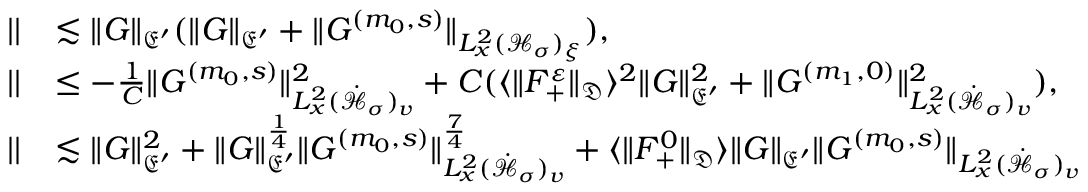<formula> <loc_0><loc_0><loc_500><loc_500>\begin{array} { r l } { | | } & { \lesssim \| G \| _ { \mathfrak E ^ { \prime } } ( \| G \| _ { \mathfrak E ^ { \prime } } + \| G ^ { ( m _ { 0 } , s ) } \| _ { L _ { x } ^ { 2 } ( \mathcal { H } _ { \sigma } ) _ { \xi } } ) , } \\ { | | } & { \leq - \frac { 1 } { C } \| G ^ { ( m _ { 0 } , s ) } \| _ { L _ { x } ^ { 2 } ( \dot { \mathcal { H } } _ { \sigma } ) _ { v } } ^ { 2 } + C ( \langle \| F _ { + } ^ { \varepsilon } \| _ { \mathfrak D } \rangle ^ { 2 } \| G \| _ { \mathfrak E ^ { \prime } } ^ { 2 } + \| G ^ { ( m _ { 1 } , 0 ) } \| _ { L _ { x } ^ { 2 } ( \dot { \mathcal { H } } _ { \sigma } ) _ { v } } ^ { 2 } ) , } \\ { | | } & { \lesssim \| G \| _ { \mathfrak E ^ { \prime } } ^ { 2 } + \| G \| _ { \mathfrak E ^ { \prime } } ^ { \frac { 1 } { 4 } } \| G ^ { ( m _ { 0 } , s ) } \| _ { L _ { x } ^ { 2 } ( \dot { \mathcal { H } } _ { \sigma } ) _ { v } } ^ { \frac { 7 } { 4 } } + \langle \| F _ { + } ^ { 0 } \| _ { \mathfrak D } \rangle \| G \| _ { \mathfrak E ^ { \prime } } \| G ^ { ( m _ { 0 } , s ) } \| _ { L _ { x } ^ { 2 } ( \dot { \mathcal { H } } _ { \sigma } ) _ { v } } } \end{array}</formula> 